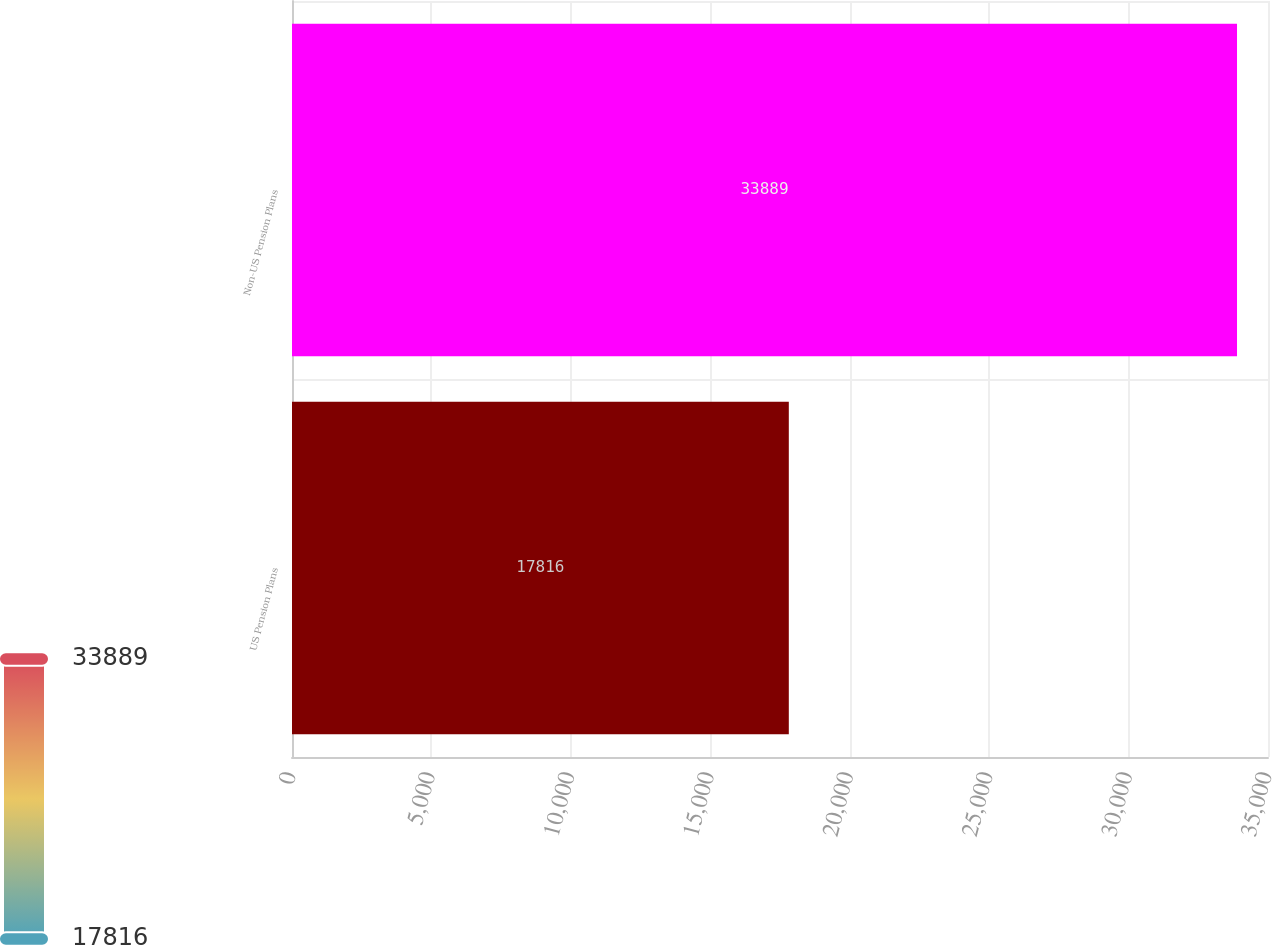Convert chart. <chart><loc_0><loc_0><loc_500><loc_500><bar_chart><fcel>US Pension Plans<fcel>Non-US Pension Plans<nl><fcel>17816<fcel>33889<nl></chart> 